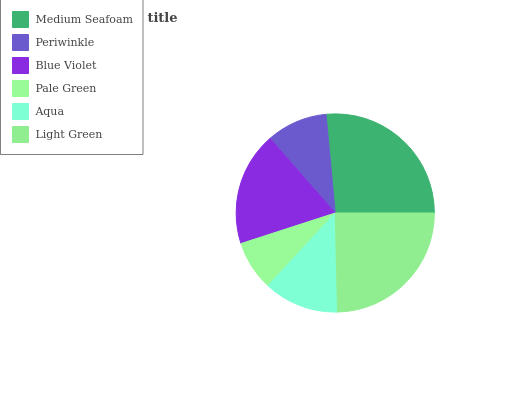Is Pale Green the minimum?
Answer yes or no. Yes. Is Medium Seafoam the maximum?
Answer yes or no. Yes. Is Periwinkle the minimum?
Answer yes or no. No. Is Periwinkle the maximum?
Answer yes or no. No. Is Medium Seafoam greater than Periwinkle?
Answer yes or no. Yes. Is Periwinkle less than Medium Seafoam?
Answer yes or no. Yes. Is Periwinkle greater than Medium Seafoam?
Answer yes or no. No. Is Medium Seafoam less than Periwinkle?
Answer yes or no. No. Is Blue Violet the high median?
Answer yes or no. Yes. Is Aqua the low median?
Answer yes or no. Yes. Is Periwinkle the high median?
Answer yes or no. No. Is Medium Seafoam the low median?
Answer yes or no. No. 